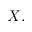Convert formula to latex. <formula><loc_0><loc_0><loc_500><loc_500>X ,</formula> 